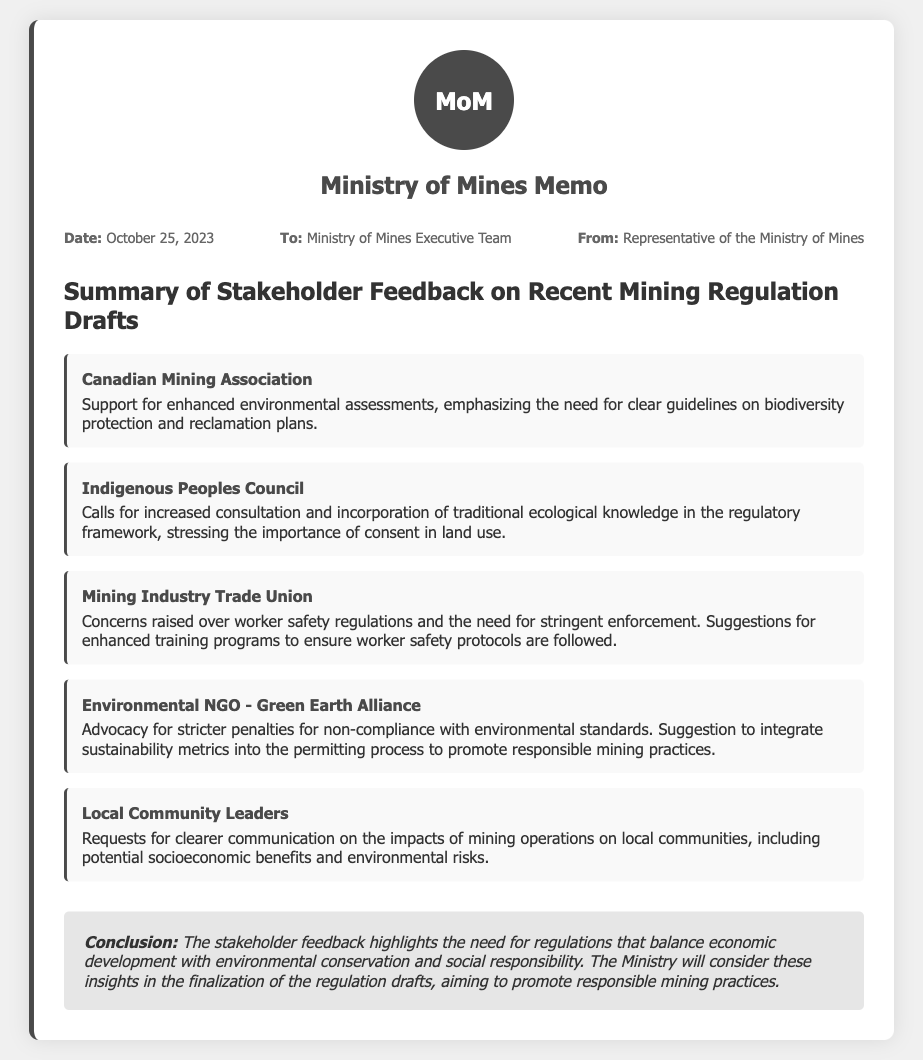What is the date of the memo? The date mentioned in the memo is explicitly stated in the meta section.
Answer: October 25, 2023 Who is the memo addressed to? The recipient of the memo is specified in the meta section.
Answer: Ministry of Mines Executive Team Which organization supports enhanced environmental assessments? The specific feedback regarding environmental assessments comes from the Canadian Mining Association, noted in the feedback section.
Answer: Canadian Mining Association What is a key concern raised by the Mining Industry Trade Union? The concern outlined in the feedback from the Mining Industry Trade Union relates to worker safety regulations.
Answer: Worker safety regulations What suggestion did the Environmental NGO - Green Earth Alliance provide? The feedback section includes an advocacy from the NGO for stricter penalties for non-compliance with environmental standards.
Answer: Stricter penalties for non-compliance What do local community leaders request regarding mining operations? Local community leaders are seeking clearer communication about mining operations impacts, as indicated in their feedback.
Answer: Clearer communication What is the overall conclusion of the feedback received? The conclusion at the end of the memo summarizes the main takeaway regarding regulations and stakeholder input.
Answer: Balance economic development with environmental conservation 